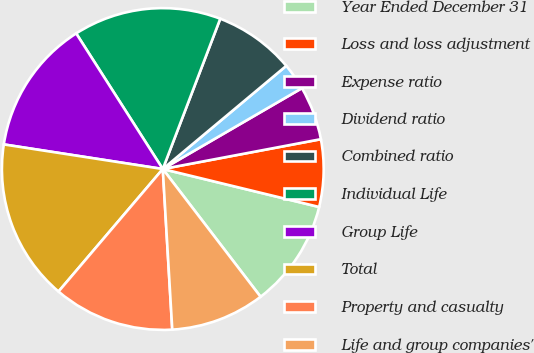Convert chart to OTSL. <chart><loc_0><loc_0><loc_500><loc_500><pie_chart><fcel>Year Ended December 31<fcel>Loss and loss adjustment<fcel>Expense ratio<fcel>Dividend ratio<fcel>Combined ratio<fcel>Individual Life<fcel>Group Life<fcel>Total<fcel>Property and casualty<fcel>Life and group companies'<nl><fcel>10.81%<fcel>6.76%<fcel>5.41%<fcel>2.7%<fcel>8.11%<fcel>14.86%<fcel>13.51%<fcel>16.22%<fcel>12.16%<fcel>9.46%<nl></chart> 